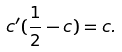Convert formula to latex. <formula><loc_0><loc_0><loc_500><loc_500>c ^ { \prime } ( \frac { 1 } { 2 } - c ) = c .</formula> 